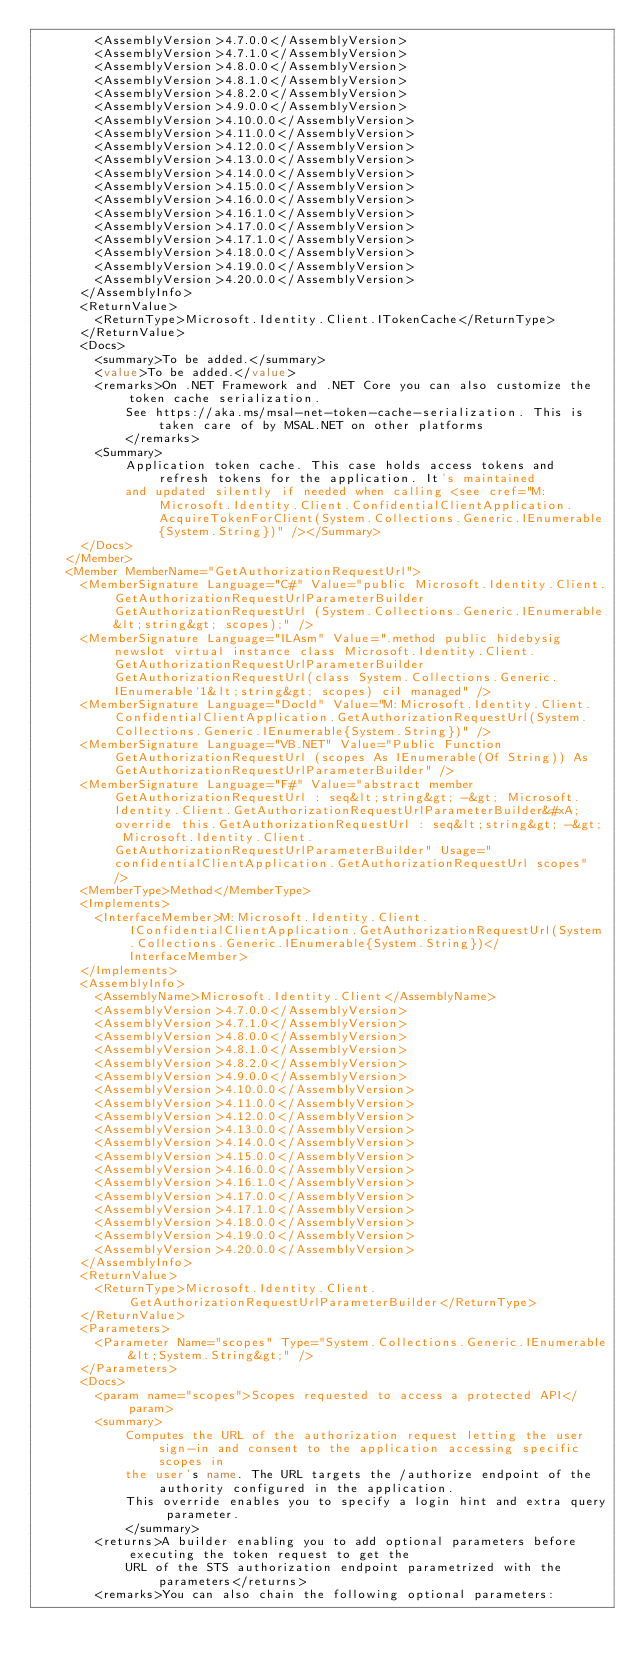<code> <loc_0><loc_0><loc_500><loc_500><_XML_>        <AssemblyVersion>4.7.0.0</AssemblyVersion>
        <AssemblyVersion>4.7.1.0</AssemblyVersion>
        <AssemblyVersion>4.8.0.0</AssemblyVersion>
        <AssemblyVersion>4.8.1.0</AssemblyVersion>
        <AssemblyVersion>4.8.2.0</AssemblyVersion>
        <AssemblyVersion>4.9.0.0</AssemblyVersion>
        <AssemblyVersion>4.10.0.0</AssemblyVersion>
        <AssemblyVersion>4.11.0.0</AssemblyVersion>
        <AssemblyVersion>4.12.0.0</AssemblyVersion>
        <AssemblyVersion>4.13.0.0</AssemblyVersion>
        <AssemblyVersion>4.14.0.0</AssemblyVersion>
        <AssemblyVersion>4.15.0.0</AssemblyVersion>
        <AssemblyVersion>4.16.0.0</AssemblyVersion>
        <AssemblyVersion>4.16.1.0</AssemblyVersion>
        <AssemblyVersion>4.17.0.0</AssemblyVersion>
        <AssemblyVersion>4.17.1.0</AssemblyVersion>
        <AssemblyVersion>4.18.0.0</AssemblyVersion>
        <AssemblyVersion>4.19.0.0</AssemblyVersion>
        <AssemblyVersion>4.20.0.0</AssemblyVersion>
      </AssemblyInfo>
      <ReturnValue>
        <ReturnType>Microsoft.Identity.Client.ITokenCache</ReturnType>
      </ReturnValue>
      <Docs>
        <summary>To be added.</summary>
        <value>To be added.</value>
        <remarks>On .NET Framework and .NET Core you can also customize the token cache serialization.
            See https://aka.ms/msal-net-token-cache-serialization. This is taken care of by MSAL.NET on other platforms
            </remarks>
        <Summary>
            Application token cache. This case holds access tokens and refresh tokens for the application. It's maintained
            and updated silently if needed when calling <see cref="M:Microsoft.Identity.Client.ConfidentialClientApplication.AcquireTokenForClient(System.Collections.Generic.IEnumerable{System.String})" /></Summary>
      </Docs>
    </Member>
    <Member MemberName="GetAuthorizationRequestUrl">
      <MemberSignature Language="C#" Value="public Microsoft.Identity.Client.GetAuthorizationRequestUrlParameterBuilder GetAuthorizationRequestUrl (System.Collections.Generic.IEnumerable&lt;string&gt; scopes);" />
      <MemberSignature Language="ILAsm" Value=".method public hidebysig newslot virtual instance class Microsoft.Identity.Client.GetAuthorizationRequestUrlParameterBuilder GetAuthorizationRequestUrl(class System.Collections.Generic.IEnumerable`1&lt;string&gt; scopes) cil managed" />
      <MemberSignature Language="DocId" Value="M:Microsoft.Identity.Client.ConfidentialClientApplication.GetAuthorizationRequestUrl(System.Collections.Generic.IEnumerable{System.String})" />
      <MemberSignature Language="VB.NET" Value="Public Function GetAuthorizationRequestUrl (scopes As IEnumerable(Of String)) As GetAuthorizationRequestUrlParameterBuilder" />
      <MemberSignature Language="F#" Value="abstract member GetAuthorizationRequestUrl : seq&lt;string&gt; -&gt; Microsoft.Identity.Client.GetAuthorizationRequestUrlParameterBuilder&#xA;override this.GetAuthorizationRequestUrl : seq&lt;string&gt; -&gt; Microsoft.Identity.Client.GetAuthorizationRequestUrlParameterBuilder" Usage="confidentialClientApplication.GetAuthorizationRequestUrl scopes" />
      <MemberType>Method</MemberType>
      <Implements>
        <InterfaceMember>M:Microsoft.Identity.Client.IConfidentialClientApplication.GetAuthorizationRequestUrl(System.Collections.Generic.IEnumerable{System.String})</InterfaceMember>
      </Implements>
      <AssemblyInfo>
        <AssemblyName>Microsoft.Identity.Client</AssemblyName>
        <AssemblyVersion>4.7.0.0</AssemblyVersion>
        <AssemblyVersion>4.7.1.0</AssemblyVersion>
        <AssemblyVersion>4.8.0.0</AssemblyVersion>
        <AssemblyVersion>4.8.1.0</AssemblyVersion>
        <AssemblyVersion>4.8.2.0</AssemblyVersion>
        <AssemblyVersion>4.9.0.0</AssemblyVersion>
        <AssemblyVersion>4.10.0.0</AssemblyVersion>
        <AssemblyVersion>4.11.0.0</AssemblyVersion>
        <AssemblyVersion>4.12.0.0</AssemblyVersion>
        <AssemblyVersion>4.13.0.0</AssemblyVersion>
        <AssemblyVersion>4.14.0.0</AssemblyVersion>
        <AssemblyVersion>4.15.0.0</AssemblyVersion>
        <AssemblyVersion>4.16.0.0</AssemblyVersion>
        <AssemblyVersion>4.16.1.0</AssemblyVersion>
        <AssemblyVersion>4.17.0.0</AssemblyVersion>
        <AssemblyVersion>4.17.1.0</AssemblyVersion>
        <AssemblyVersion>4.18.0.0</AssemblyVersion>
        <AssemblyVersion>4.19.0.0</AssemblyVersion>
        <AssemblyVersion>4.20.0.0</AssemblyVersion>
      </AssemblyInfo>
      <ReturnValue>
        <ReturnType>Microsoft.Identity.Client.GetAuthorizationRequestUrlParameterBuilder</ReturnType>
      </ReturnValue>
      <Parameters>
        <Parameter Name="scopes" Type="System.Collections.Generic.IEnumerable&lt;System.String&gt;" />
      </Parameters>
      <Docs>
        <param name="scopes">Scopes requested to access a protected API</param>
        <summary>
            Computes the URL of the authorization request letting the user sign-in and consent to the application accessing specific scopes in
            the user's name. The URL targets the /authorize endpoint of the authority configured in the application.
            This override enables you to specify a login hint and extra query parameter.
            </summary>
        <returns>A builder enabling you to add optional parameters before executing the token request to get the
            URL of the STS authorization endpoint parametrized with the parameters</returns>
        <remarks>You can also chain the following optional parameters:</code> 